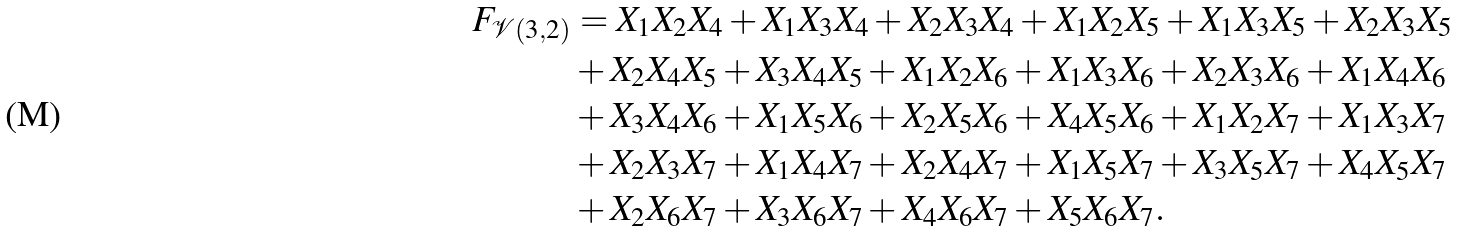<formula> <loc_0><loc_0><loc_500><loc_500>F _ { { \mathcal { V } } ( 3 , 2 ) } & = X _ { 1 } X _ { 2 } X _ { 4 } + X _ { 1 } X _ { 3 } X _ { 4 } + X _ { 2 } X _ { 3 } X _ { 4 } + X _ { 1 } X _ { 2 } X _ { 5 } + X _ { 1 } X _ { 3 } X _ { 5 } + X _ { 2 } X _ { 3 } X _ { 5 } \\ & + X _ { 2 } X _ { 4 } X _ { 5 } + X _ { 3 } X _ { 4 } X _ { 5 } + X _ { 1 } X _ { 2 } X _ { 6 } + X _ { 1 } X _ { 3 } X _ { 6 } + X _ { 2 } X _ { 3 } X _ { 6 } + X _ { 1 } X _ { 4 } X _ { 6 } \\ & + X _ { 3 } X _ { 4 } X _ { 6 } + X _ { 1 } X _ { 5 } X _ { 6 } + X _ { 2 } X _ { 5 } X _ { 6 } + X _ { 4 } X _ { 5 } X _ { 6 } + X _ { 1 } X _ { 2 } X _ { 7 } + X _ { 1 } X _ { 3 } X _ { 7 } \\ & + X _ { 2 } X _ { 3 } X _ { 7 } + X _ { 1 } X _ { 4 } X _ { 7 } + X _ { 2 } X _ { 4 } X _ { 7 } + X _ { 1 } X _ { 5 } X _ { 7 } + X _ { 3 } X _ { 5 } X _ { 7 } + X _ { 4 } X _ { 5 } X _ { 7 } \\ & + X _ { 2 } X _ { 6 } X _ { 7 } + X _ { 3 } X _ { 6 } X _ { 7 } + X _ { 4 } X _ { 6 } X _ { 7 } + X _ { 5 } X _ { 6 } X _ { 7 } .</formula> 